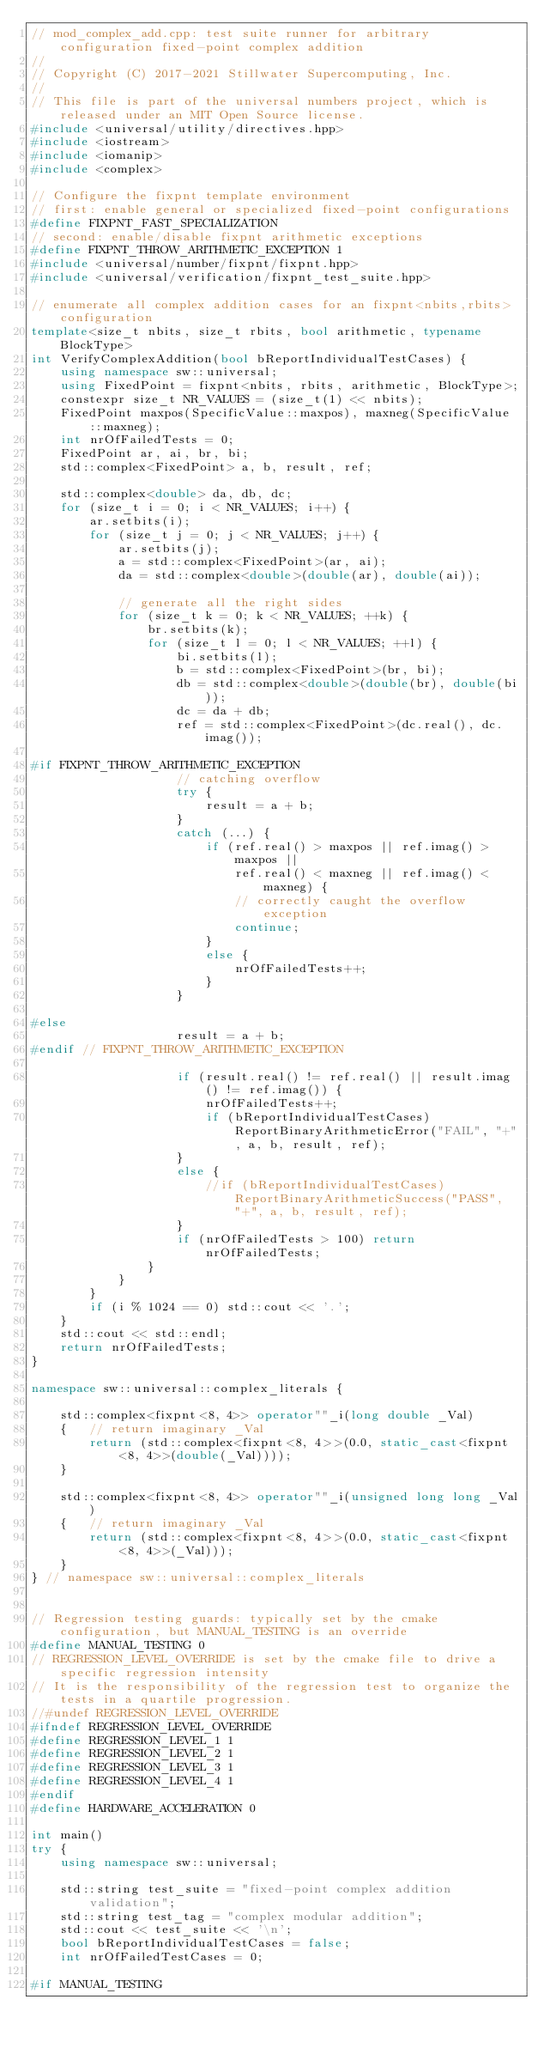<code> <loc_0><loc_0><loc_500><loc_500><_C++_>// mod_complex_add.cpp: test suite runner for arbitrary configuration fixed-point complex addition
//
// Copyright (C) 2017-2021 Stillwater Supercomputing, Inc.
//
// This file is part of the universal numbers project, which is released under an MIT Open Source license.
#include <universal/utility/directives.hpp>
#include <iostream>
#include <iomanip>
#include <complex>

// Configure the fixpnt template environment
// first: enable general or specialized fixed-point configurations
#define FIXPNT_FAST_SPECIALIZATION
// second: enable/disable fixpnt arithmetic exceptions
#define FIXPNT_THROW_ARITHMETIC_EXCEPTION 1
#include <universal/number/fixpnt/fixpnt.hpp>
#include <universal/verification/fixpnt_test_suite.hpp>

// enumerate all complex addition cases for an fixpnt<nbits,rbits> configuration
template<size_t nbits, size_t rbits, bool arithmetic, typename BlockType>
int VerifyComplexAddition(bool bReportIndividualTestCases) {
	using namespace sw::universal;
	using FixedPoint = fixpnt<nbits, rbits, arithmetic, BlockType>;
	constexpr size_t NR_VALUES = (size_t(1) << nbits);
	FixedPoint maxpos(SpecificValue::maxpos), maxneg(SpecificValue::maxneg);
	int nrOfFailedTests = 0;
	FixedPoint ar, ai, br, bi;
	std::complex<FixedPoint> a, b, result, ref;

	std::complex<double> da, db, dc;
	for (size_t i = 0; i < NR_VALUES; i++) {
		ar.setbits(i);
		for (size_t j = 0; j < NR_VALUES; j++) {
			ar.setbits(j);
			a = std::complex<FixedPoint>(ar, ai);
			da = std::complex<double>(double(ar), double(ai));

			// generate all the right sides
			for (size_t k = 0; k < NR_VALUES; ++k) {
				br.setbits(k);
				for (size_t l = 0; l < NR_VALUES; ++l) {
					bi.setbits(l);
					b = std::complex<FixedPoint>(br, bi);
					db = std::complex<double>(double(br), double(bi));
					dc = da + db;
					ref = std::complex<FixedPoint>(dc.real(), dc.imag());

#if FIXPNT_THROW_ARITHMETIC_EXCEPTION
					// catching overflow
					try {
						result = a + b;
					}
					catch (...) {
						if (ref.real() > maxpos || ref.imag() > maxpos ||
							ref.real() < maxneg || ref.imag() < maxneg) {
							// correctly caught the overflow exception
							continue;
						}
						else {
							nrOfFailedTests++;
						}
					}

#else
					result = a + b;
#endif // FIXPNT_THROW_ARITHMETIC_EXCEPTION

					if (result.real() != ref.real() || result.imag() != ref.imag()) {
						nrOfFailedTests++;
						if (bReportIndividualTestCases) ReportBinaryArithmeticError("FAIL", "+", a, b, result, ref);
					}
					else {
						//if (bReportIndividualTestCases) ReportBinaryArithmeticSuccess("PASS", "+", a, b, result, ref);
					}
					if (nrOfFailedTests > 100) return nrOfFailedTests;
				}
			}
		}
		if (i % 1024 == 0) std::cout << '.';
	}
	std::cout << std::endl;
	return nrOfFailedTests;
}

namespace sw::universal::complex_literals {

	std::complex<fixpnt<8, 4>> operator""_i(long double _Val)
	{	// return imaginary _Val
		return (std::complex<fixpnt<8, 4>>(0.0, static_cast<fixpnt<8, 4>>(double(_Val))));
	}

	std::complex<fixpnt<8, 4>> operator""_i(unsigned long long _Val)
	{	// return imaginary _Val
		return (std::complex<fixpnt<8, 4>>(0.0, static_cast<fixpnt<8, 4>>(_Val)));
	}
} // namespace sw::universal::complex_literals


// Regression testing guards: typically set by the cmake configuration, but MANUAL_TESTING is an override
#define MANUAL_TESTING 0
// REGRESSION_LEVEL_OVERRIDE is set by the cmake file to drive a specific regression intensity
// It is the responsibility of the regression test to organize the tests in a quartile progression.
//#undef REGRESSION_LEVEL_OVERRIDE
#ifndef REGRESSION_LEVEL_OVERRIDE
#define REGRESSION_LEVEL_1 1
#define REGRESSION_LEVEL_2 1
#define REGRESSION_LEVEL_3 1
#define REGRESSION_LEVEL_4 1
#endif
#define HARDWARE_ACCELERATION 0

int main()
try {
	using namespace sw::universal;

	std::string test_suite = "fixed-point complex addition validation";
	std::string test_tag = "complex modular addition";
	std::cout << test_suite << '\n';
	bool bReportIndividualTestCases = false;
	int nrOfFailedTestCases = 0;

#if MANUAL_TESTING
</code> 